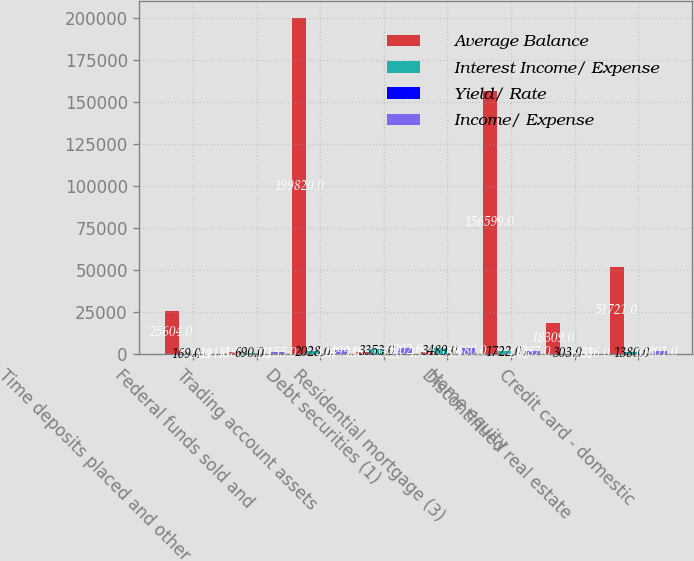<chart> <loc_0><loc_0><loc_500><loc_500><stacked_bar_chart><ecel><fcel>Time deposits placed and other<fcel>Federal funds sold and<fcel>Trading account assets<fcel>Debt securities (1)<fcel>Residential mortgage (3)<fcel>Home equity<fcel>Discontinued real estate<fcel>Credit card - domestic<nl><fcel>Average Balance<fcel>25604<fcel>1380<fcel>199820<fcel>1380<fcel>1380<fcel>156599<fcel>18309<fcel>51721<nl><fcel>Interest Income/ Expense<fcel>169<fcel>690<fcel>2028<fcel>3353<fcel>3489<fcel>1722<fcel>303<fcel>1380<nl><fcel>Yield/ Rate<fcel>2.64<fcel>1.2<fcel>4.07<fcel>5.26<fcel>5.5<fcel>4.41<fcel>6.61<fcel>10.7<nl><fcel>Income/ Expense<fcel>191<fcel>1155<fcel>2499<fcel>3902<fcel>3680<fcel>1787<fcel>386<fcel>1601<nl></chart> 